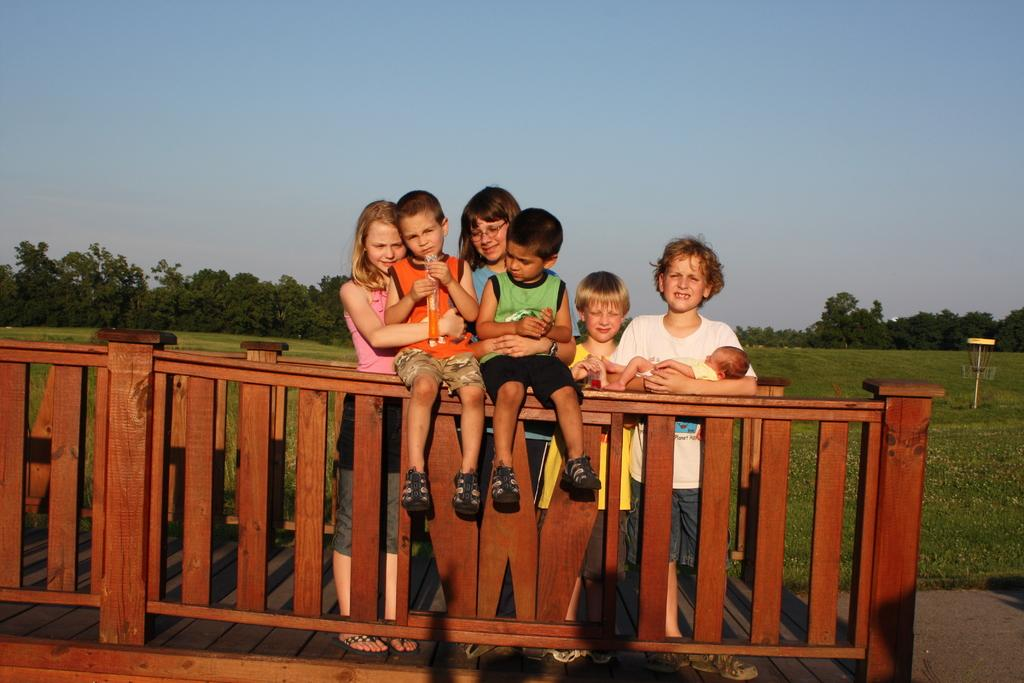What are the people doing on the wooden path in the image? The people are standing on the wooden path and making their kids sit on the railing. What can be seen in the distance from the wooden path? Trees are visible in the distance from the wooden path. What is visible in the sky in the image? The sky is visible in the image. How many bottles of ink are visible on the wooden path in the image? There are no bottles of ink visible on the wooden path in the image. What type of land is visible in the image? The image does not provide information about the type of land visible; it only shows a wooden path, people, and trees in the distance. 